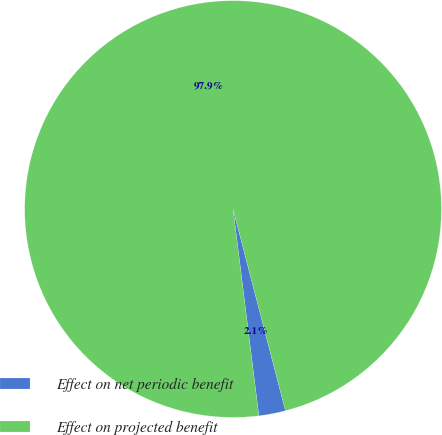<chart> <loc_0><loc_0><loc_500><loc_500><pie_chart><fcel>Effect on net periodic benefit<fcel>Effect on projected benefit<nl><fcel>2.07%<fcel>97.93%<nl></chart> 